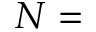<formula> <loc_0><loc_0><loc_500><loc_500>N =</formula> 